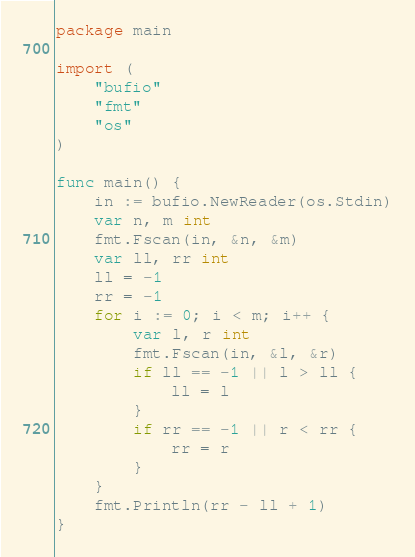<code> <loc_0><loc_0><loc_500><loc_500><_Go_>package main

import (
	"bufio"
	"fmt"
	"os"
)

func main() {
	in := bufio.NewReader(os.Stdin)
	var n, m int
	fmt.Fscan(in, &n, &m)
	var ll, rr int
	ll = -1
	rr = -1
	for i := 0; i < m; i++ {
		var l, r int
		fmt.Fscan(in, &l, &r)
		if ll == -1 || l > ll {
			ll = l
		}
		if rr == -1 || r < rr {
			rr = r
		}
	}
	fmt.Println(rr - ll + 1)
}
</code> 